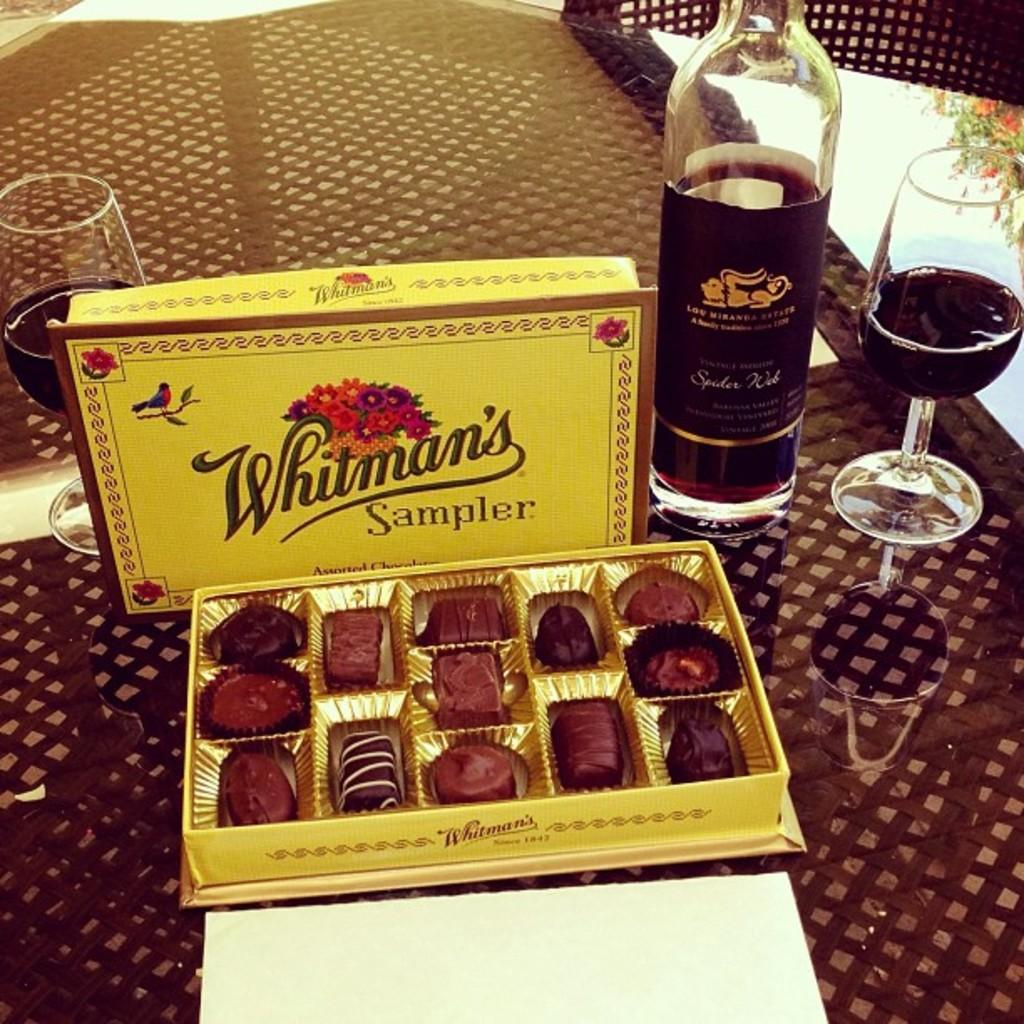What is the main object in the image? There is a chocolate box in the image. What else can be seen in the image besides the chocolate box? There is a bottle and two glasses in the image. What is the price of the meat in the image? There is no meat present in the image, so it is not possible to determine its price. 